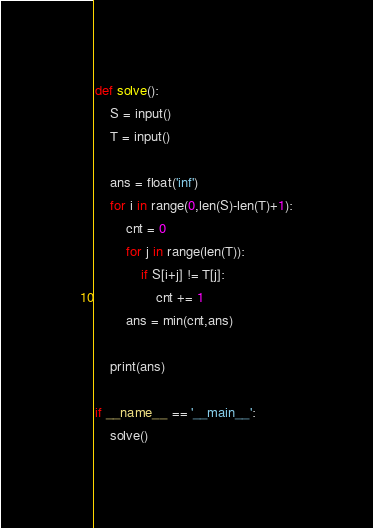<code> <loc_0><loc_0><loc_500><loc_500><_Python_>def solve():
    S = input()
    T = input()

    ans = float('inf')
    for i in range(0,len(S)-len(T)+1):
        cnt = 0
        for j in range(len(T)):
            if S[i+j] != T[j]:
                cnt += 1
        ans = min(cnt,ans)
    
    print(ans)

if __name__ == '__main__':
    solve()
</code> 